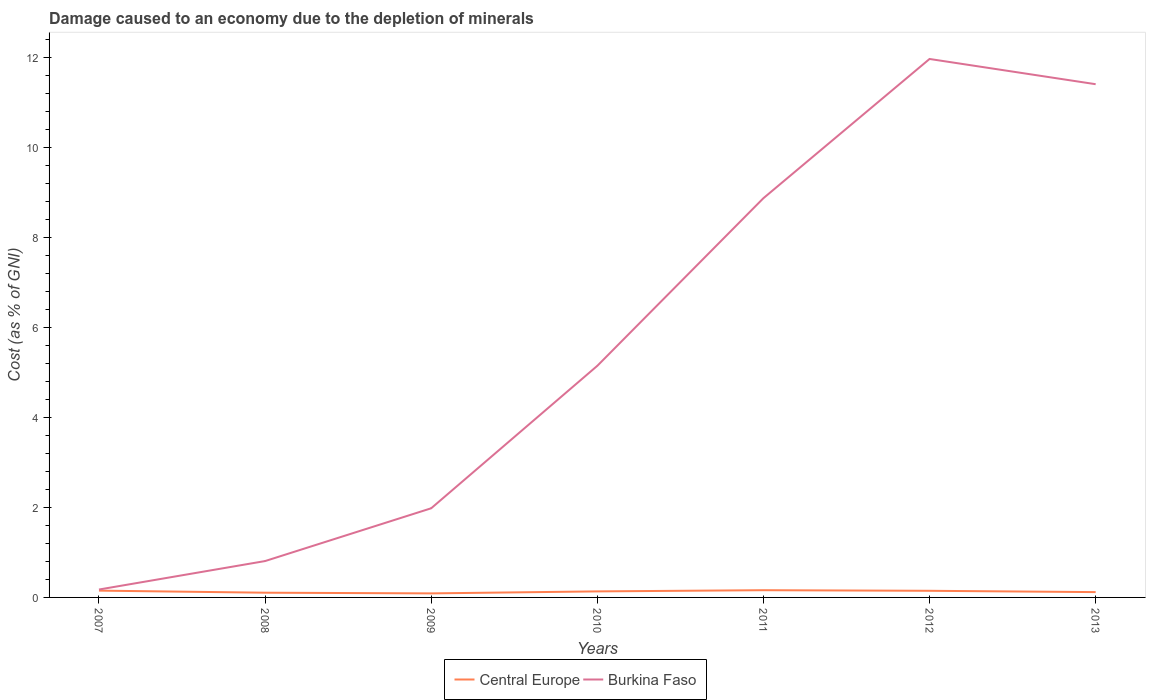Does the line corresponding to Central Europe intersect with the line corresponding to Burkina Faso?
Give a very brief answer. No. Across all years, what is the maximum cost of damage caused due to the depletion of minerals in Burkina Faso?
Offer a very short reply. 0.18. What is the total cost of damage caused due to the depletion of minerals in Burkina Faso in the graph?
Offer a very short reply. -3.73. What is the difference between the highest and the second highest cost of damage caused due to the depletion of minerals in Burkina Faso?
Provide a succinct answer. 11.79. What is the difference between two consecutive major ticks on the Y-axis?
Ensure brevity in your answer.  2. Are the values on the major ticks of Y-axis written in scientific E-notation?
Offer a very short reply. No. Does the graph contain grids?
Offer a terse response. No. How are the legend labels stacked?
Keep it short and to the point. Horizontal. What is the title of the graph?
Provide a succinct answer. Damage caused to an economy due to the depletion of minerals. What is the label or title of the Y-axis?
Give a very brief answer. Cost (as % of GNI). What is the Cost (as % of GNI) of Central Europe in 2007?
Offer a terse response. 0.15. What is the Cost (as % of GNI) in Burkina Faso in 2007?
Your answer should be very brief. 0.18. What is the Cost (as % of GNI) of Central Europe in 2008?
Keep it short and to the point. 0.1. What is the Cost (as % of GNI) of Burkina Faso in 2008?
Ensure brevity in your answer.  0.81. What is the Cost (as % of GNI) in Central Europe in 2009?
Provide a short and direct response. 0.09. What is the Cost (as % of GNI) in Burkina Faso in 2009?
Offer a very short reply. 1.98. What is the Cost (as % of GNI) of Central Europe in 2010?
Ensure brevity in your answer.  0.13. What is the Cost (as % of GNI) of Burkina Faso in 2010?
Keep it short and to the point. 5.15. What is the Cost (as % of GNI) in Central Europe in 2011?
Your answer should be compact. 0.16. What is the Cost (as % of GNI) in Burkina Faso in 2011?
Offer a terse response. 8.88. What is the Cost (as % of GNI) in Central Europe in 2012?
Offer a very short reply. 0.15. What is the Cost (as % of GNI) of Burkina Faso in 2012?
Your response must be concise. 11.97. What is the Cost (as % of GNI) of Central Europe in 2013?
Your response must be concise. 0.12. What is the Cost (as % of GNI) of Burkina Faso in 2013?
Your response must be concise. 11.41. Across all years, what is the maximum Cost (as % of GNI) of Central Europe?
Ensure brevity in your answer.  0.16. Across all years, what is the maximum Cost (as % of GNI) of Burkina Faso?
Offer a terse response. 11.97. Across all years, what is the minimum Cost (as % of GNI) of Central Europe?
Ensure brevity in your answer.  0.09. Across all years, what is the minimum Cost (as % of GNI) of Burkina Faso?
Make the answer very short. 0.18. What is the total Cost (as % of GNI) of Central Europe in the graph?
Offer a very short reply. 0.91. What is the total Cost (as % of GNI) of Burkina Faso in the graph?
Offer a very short reply. 40.37. What is the difference between the Cost (as % of GNI) of Central Europe in 2007 and that in 2008?
Give a very brief answer. 0.05. What is the difference between the Cost (as % of GNI) in Burkina Faso in 2007 and that in 2008?
Ensure brevity in your answer.  -0.63. What is the difference between the Cost (as % of GNI) of Central Europe in 2007 and that in 2009?
Your answer should be compact. 0.06. What is the difference between the Cost (as % of GNI) of Burkina Faso in 2007 and that in 2009?
Ensure brevity in your answer.  -1.81. What is the difference between the Cost (as % of GNI) in Central Europe in 2007 and that in 2010?
Provide a short and direct response. 0.02. What is the difference between the Cost (as % of GNI) of Burkina Faso in 2007 and that in 2010?
Offer a terse response. -4.97. What is the difference between the Cost (as % of GNI) in Central Europe in 2007 and that in 2011?
Your response must be concise. -0.01. What is the difference between the Cost (as % of GNI) of Burkina Faso in 2007 and that in 2011?
Offer a very short reply. -8.7. What is the difference between the Cost (as % of GNI) in Central Europe in 2007 and that in 2012?
Your answer should be compact. 0. What is the difference between the Cost (as % of GNI) in Burkina Faso in 2007 and that in 2012?
Ensure brevity in your answer.  -11.79. What is the difference between the Cost (as % of GNI) of Central Europe in 2007 and that in 2013?
Make the answer very short. 0.03. What is the difference between the Cost (as % of GNI) in Burkina Faso in 2007 and that in 2013?
Your answer should be very brief. -11.23. What is the difference between the Cost (as % of GNI) in Central Europe in 2008 and that in 2009?
Offer a terse response. 0.02. What is the difference between the Cost (as % of GNI) of Burkina Faso in 2008 and that in 2009?
Your response must be concise. -1.17. What is the difference between the Cost (as % of GNI) in Central Europe in 2008 and that in 2010?
Your answer should be very brief. -0.03. What is the difference between the Cost (as % of GNI) of Burkina Faso in 2008 and that in 2010?
Make the answer very short. -4.34. What is the difference between the Cost (as % of GNI) of Central Europe in 2008 and that in 2011?
Ensure brevity in your answer.  -0.06. What is the difference between the Cost (as % of GNI) in Burkina Faso in 2008 and that in 2011?
Give a very brief answer. -8.07. What is the difference between the Cost (as % of GNI) in Central Europe in 2008 and that in 2012?
Offer a very short reply. -0.04. What is the difference between the Cost (as % of GNI) of Burkina Faso in 2008 and that in 2012?
Your response must be concise. -11.16. What is the difference between the Cost (as % of GNI) of Central Europe in 2008 and that in 2013?
Your answer should be very brief. -0.01. What is the difference between the Cost (as % of GNI) in Burkina Faso in 2008 and that in 2013?
Your answer should be very brief. -10.6. What is the difference between the Cost (as % of GNI) in Central Europe in 2009 and that in 2010?
Your answer should be very brief. -0.04. What is the difference between the Cost (as % of GNI) in Burkina Faso in 2009 and that in 2010?
Offer a very short reply. -3.17. What is the difference between the Cost (as % of GNI) of Central Europe in 2009 and that in 2011?
Your answer should be very brief. -0.07. What is the difference between the Cost (as % of GNI) in Burkina Faso in 2009 and that in 2011?
Make the answer very short. -6.89. What is the difference between the Cost (as % of GNI) of Central Europe in 2009 and that in 2012?
Make the answer very short. -0.06. What is the difference between the Cost (as % of GNI) in Burkina Faso in 2009 and that in 2012?
Provide a short and direct response. -9.99. What is the difference between the Cost (as % of GNI) of Central Europe in 2009 and that in 2013?
Your response must be concise. -0.03. What is the difference between the Cost (as % of GNI) of Burkina Faso in 2009 and that in 2013?
Make the answer very short. -9.43. What is the difference between the Cost (as % of GNI) of Central Europe in 2010 and that in 2011?
Make the answer very short. -0.03. What is the difference between the Cost (as % of GNI) in Burkina Faso in 2010 and that in 2011?
Your answer should be compact. -3.73. What is the difference between the Cost (as % of GNI) of Central Europe in 2010 and that in 2012?
Provide a succinct answer. -0.01. What is the difference between the Cost (as % of GNI) of Burkina Faso in 2010 and that in 2012?
Your answer should be very brief. -6.82. What is the difference between the Cost (as % of GNI) in Central Europe in 2010 and that in 2013?
Your response must be concise. 0.02. What is the difference between the Cost (as % of GNI) of Burkina Faso in 2010 and that in 2013?
Ensure brevity in your answer.  -6.26. What is the difference between the Cost (as % of GNI) of Central Europe in 2011 and that in 2012?
Make the answer very short. 0.01. What is the difference between the Cost (as % of GNI) in Burkina Faso in 2011 and that in 2012?
Offer a terse response. -3.09. What is the difference between the Cost (as % of GNI) in Central Europe in 2011 and that in 2013?
Ensure brevity in your answer.  0.04. What is the difference between the Cost (as % of GNI) in Burkina Faso in 2011 and that in 2013?
Your answer should be very brief. -2.53. What is the difference between the Cost (as % of GNI) of Central Europe in 2012 and that in 2013?
Your response must be concise. 0.03. What is the difference between the Cost (as % of GNI) of Burkina Faso in 2012 and that in 2013?
Your response must be concise. 0.56. What is the difference between the Cost (as % of GNI) of Central Europe in 2007 and the Cost (as % of GNI) of Burkina Faso in 2008?
Your answer should be compact. -0.66. What is the difference between the Cost (as % of GNI) in Central Europe in 2007 and the Cost (as % of GNI) in Burkina Faso in 2009?
Provide a short and direct response. -1.83. What is the difference between the Cost (as % of GNI) in Central Europe in 2007 and the Cost (as % of GNI) in Burkina Faso in 2010?
Your answer should be very brief. -5. What is the difference between the Cost (as % of GNI) of Central Europe in 2007 and the Cost (as % of GNI) of Burkina Faso in 2011?
Your answer should be compact. -8.72. What is the difference between the Cost (as % of GNI) of Central Europe in 2007 and the Cost (as % of GNI) of Burkina Faso in 2012?
Offer a very short reply. -11.82. What is the difference between the Cost (as % of GNI) in Central Europe in 2007 and the Cost (as % of GNI) in Burkina Faso in 2013?
Your answer should be compact. -11.26. What is the difference between the Cost (as % of GNI) in Central Europe in 2008 and the Cost (as % of GNI) in Burkina Faso in 2009?
Your answer should be compact. -1.88. What is the difference between the Cost (as % of GNI) of Central Europe in 2008 and the Cost (as % of GNI) of Burkina Faso in 2010?
Ensure brevity in your answer.  -5.04. What is the difference between the Cost (as % of GNI) of Central Europe in 2008 and the Cost (as % of GNI) of Burkina Faso in 2011?
Provide a short and direct response. -8.77. What is the difference between the Cost (as % of GNI) of Central Europe in 2008 and the Cost (as % of GNI) of Burkina Faso in 2012?
Your response must be concise. -11.87. What is the difference between the Cost (as % of GNI) of Central Europe in 2008 and the Cost (as % of GNI) of Burkina Faso in 2013?
Give a very brief answer. -11.3. What is the difference between the Cost (as % of GNI) in Central Europe in 2009 and the Cost (as % of GNI) in Burkina Faso in 2010?
Ensure brevity in your answer.  -5.06. What is the difference between the Cost (as % of GNI) of Central Europe in 2009 and the Cost (as % of GNI) of Burkina Faso in 2011?
Provide a short and direct response. -8.79. What is the difference between the Cost (as % of GNI) in Central Europe in 2009 and the Cost (as % of GNI) in Burkina Faso in 2012?
Give a very brief answer. -11.88. What is the difference between the Cost (as % of GNI) in Central Europe in 2009 and the Cost (as % of GNI) in Burkina Faso in 2013?
Offer a very short reply. -11.32. What is the difference between the Cost (as % of GNI) in Central Europe in 2010 and the Cost (as % of GNI) in Burkina Faso in 2011?
Ensure brevity in your answer.  -8.74. What is the difference between the Cost (as % of GNI) of Central Europe in 2010 and the Cost (as % of GNI) of Burkina Faso in 2012?
Keep it short and to the point. -11.84. What is the difference between the Cost (as % of GNI) in Central Europe in 2010 and the Cost (as % of GNI) in Burkina Faso in 2013?
Your response must be concise. -11.28. What is the difference between the Cost (as % of GNI) in Central Europe in 2011 and the Cost (as % of GNI) in Burkina Faso in 2012?
Provide a succinct answer. -11.81. What is the difference between the Cost (as % of GNI) of Central Europe in 2011 and the Cost (as % of GNI) of Burkina Faso in 2013?
Keep it short and to the point. -11.25. What is the difference between the Cost (as % of GNI) of Central Europe in 2012 and the Cost (as % of GNI) of Burkina Faso in 2013?
Make the answer very short. -11.26. What is the average Cost (as % of GNI) of Central Europe per year?
Offer a very short reply. 0.13. What is the average Cost (as % of GNI) in Burkina Faso per year?
Offer a terse response. 5.77. In the year 2007, what is the difference between the Cost (as % of GNI) of Central Europe and Cost (as % of GNI) of Burkina Faso?
Your response must be concise. -0.02. In the year 2008, what is the difference between the Cost (as % of GNI) in Central Europe and Cost (as % of GNI) in Burkina Faso?
Offer a terse response. -0.7. In the year 2009, what is the difference between the Cost (as % of GNI) in Central Europe and Cost (as % of GNI) in Burkina Faso?
Your response must be concise. -1.89. In the year 2010, what is the difference between the Cost (as % of GNI) of Central Europe and Cost (as % of GNI) of Burkina Faso?
Ensure brevity in your answer.  -5.01. In the year 2011, what is the difference between the Cost (as % of GNI) of Central Europe and Cost (as % of GNI) of Burkina Faso?
Keep it short and to the point. -8.72. In the year 2012, what is the difference between the Cost (as % of GNI) of Central Europe and Cost (as % of GNI) of Burkina Faso?
Ensure brevity in your answer.  -11.82. In the year 2013, what is the difference between the Cost (as % of GNI) of Central Europe and Cost (as % of GNI) of Burkina Faso?
Offer a terse response. -11.29. What is the ratio of the Cost (as % of GNI) in Central Europe in 2007 to that in 2008?
Provide a short and direct response. 1.44. What is the ratio of the Cost (as % of GNI) of Burkina Faso in 2007 to that in 2008?
Your response must be concise. 0.22. What is the ratio of the Cost (as % of GNI) in Central Europe in 2007 to that in 2009?
Ensure brevity in your answer.  1.69. What is the ratio of the Cost (as % of GNI) in Burkina Faso in 2007 to that in 2009?
Your answer should be compact. 0.09. What is the ratio of the Cost (as % of GNI) of Central Europe in 2007 to that in 2010?
Offer a terse response. 1.13. What is the ratio of the Cost (as % of GNI) of Burkina Faso in 2007 to that in 2010?
Your answer should be compact. 0.03. What is the ratio of the Cost (as % of GNI) in Central Europe in 2007 to that in 2011?
Your answer should be very brief. 0.94. What is the ratio of the Cost (as % of GNI) of Burkina Faso in 2007 to that in 2011?
Your answer should be very brief. 0.02. What is the ratio of the Cost (as % of GNI) in Central Europe in 2007 to that in 2012?
Offer a very short reply. 1.03. What is the ratio of the Cost (as % of GNI) of Burkina Faso in 2007 to that in 2012?
Offer a very short reply. 0.01. What is the ratio of the Cost (as % of GNI) of Central Europe in 2007 to that in 2013?
Your answer should be very brief. 1.28. What is the ratio of the Cost (as % of GNI) in Burkina Faso in 2007 to that in 2013?
Your answer should be compact. 0.02. What is the ratio of the Cost (as % of GNI) in Central Europe in 2008 to that in 2009?
Offer a very short reply. 1.17. What is the ratio of the Cost (as % of GNI) of Burkina Faso in 2008 to that in 2009?
Ensure brevity in your answer.  0.41. What is the ratio of the Cost (as % of GNI) in Central Europe in 2008 to that in 2010?
Provide a succinct answer. 0.78. What is the ratio of the Cost (as % of GNI) in Burkina Faso in 2008 to that in 2010?
Offer a terse response. 0.16. What is the ratio of the Cost (as % of GNI) in Central Europe in 2008 to that in 2011?
Give a very brief answer. 0.65. What is the ratio of the Cost (as % of GNI) of Burkina Faso in 2008 to that in 2011?
Offer a terse response. 0.09. What is the ratio of the Cost (as % of GNI) in Central Europe in 2008 to that in 2012?
Your answer should be very brief. 0.71. What is the ratio of the Cost (as % of GNI) in Burkina Faso in 2008 to that in 2012?
Your response must be concise. 0.07. What is the ratio of the Cost (as % of GNI) of Central Europe in 2008 to that in 2013?
Give a very brief answer. 0.89. What is the ratio of the Cost (as % of GNI) in Burkina Faso in 2008 to that in 2013?
Your response must be concise. 0.07. What is the ratio of the Cost (as % of GNI) of Central Europe in 2009 to that in 2010?
Give a very brief answer. 0.67. What is the ratio of the Cost (as % of GNI) in Burkina Faso in 2009 to that in 2010?
Keep it short and to the point. 0.38. What is the ratio of the Cost (as % of GNI) in Central Europe in 2009 to that in 2011?
Your answer should be compact. 0.56. What is the ratio of the Cost (as % of GNI) of Burkina Faso in 2009 to that in 2011?
Give a very brief answer. 0.22. What is the ratio of the Cost (as % of GNI) of Central Europe in 2009 to that in 2012?
Give a very brief answer. 0.61. What is the ratio of the Cost (as % of GNI) of Burkina Faso in 2009 to that in 2012?
Offer a terse response. 0.17. What is the ratio of the Cost (as % of GNI) in Central Europe in 2009 to that in 2013?
Offer a very short reply. 0.76. What is the ratio of the Cost (as % of GNI) of Burkina Faso in 2009 to that in 2013?
Provide a succinct answer. 0.17. What is the ratio of the Cost (as % of GNI) in Central Europe in 2010 to that in 2011?
Your answer should be compact. 0.84. What is the ratio of the Cost (as % of GNI) in Burkina Faso in 2010 to that in 2011?
Provide a succinct answer. 0.58. What is the ratio of the Cost (as % of GNI) in Central Europe in 2010 to that in 2012?
Offer a terse response. 0.91. What is the ratio of the Cost (as % of GNI) of Burkina Faso in 2010 to that in 2012?
Offer a terse response. 0.43. What is the ratio of the Cost (as % of GNI) in Central Europe in 2010 to that in 2013?
Your answer should be compact. 1.13. What is the ratio of the Cost (as % of GNI) in Burkina Faso in 2010 to that in 2013?
Ensure brevity in your answer.  0.45. What is the ratio of the Cost (as % of GNI) in Central Europe in 2011 to that in 2012?
Your response must be concise. 1.09. What is the ratio of the Cost (as % of GNI) of Burkina Faso in 2011 to that in 2012?
Keep it short and to the point. 0.74. What is the ratio of the Cost (as % of GNI) in Central Europe in 2011 to that in 2013?
Offer a terse response. 1.36. What is the ratio of the Cost (as % of GNI) of Burkina Faso in 2011 to that in 2013?
Your response must be concise. 0.78. What is the ratio of the Cost (as % of GNI) of Central Europe in 2012 to that in 2013?
Your answer should be very brief. 1.25. What is the ratio of the Cost (as % of GNI) of Burkina Faso in 2012 to that in 2013?
Provide a succinct answer. 1.05. What is the difference between the highest and the second highest Cost (as % of GNI) in Central Europe?
Ensure brevity in your answer.  0.01. What is the difference between the highest and the second highest Cost (as % of GNI) in Burkina Faso?
Offer a very short reply. 0.56. What is the difference between the highest and the lowest Cost (as % of GNI) in Central Europe?
Your response must be concise. 0.07. What is the difference between the highest and the lowest Cost (as % of GNI) in Burkina Faso?
Provide a short and direct response. 11.79. 